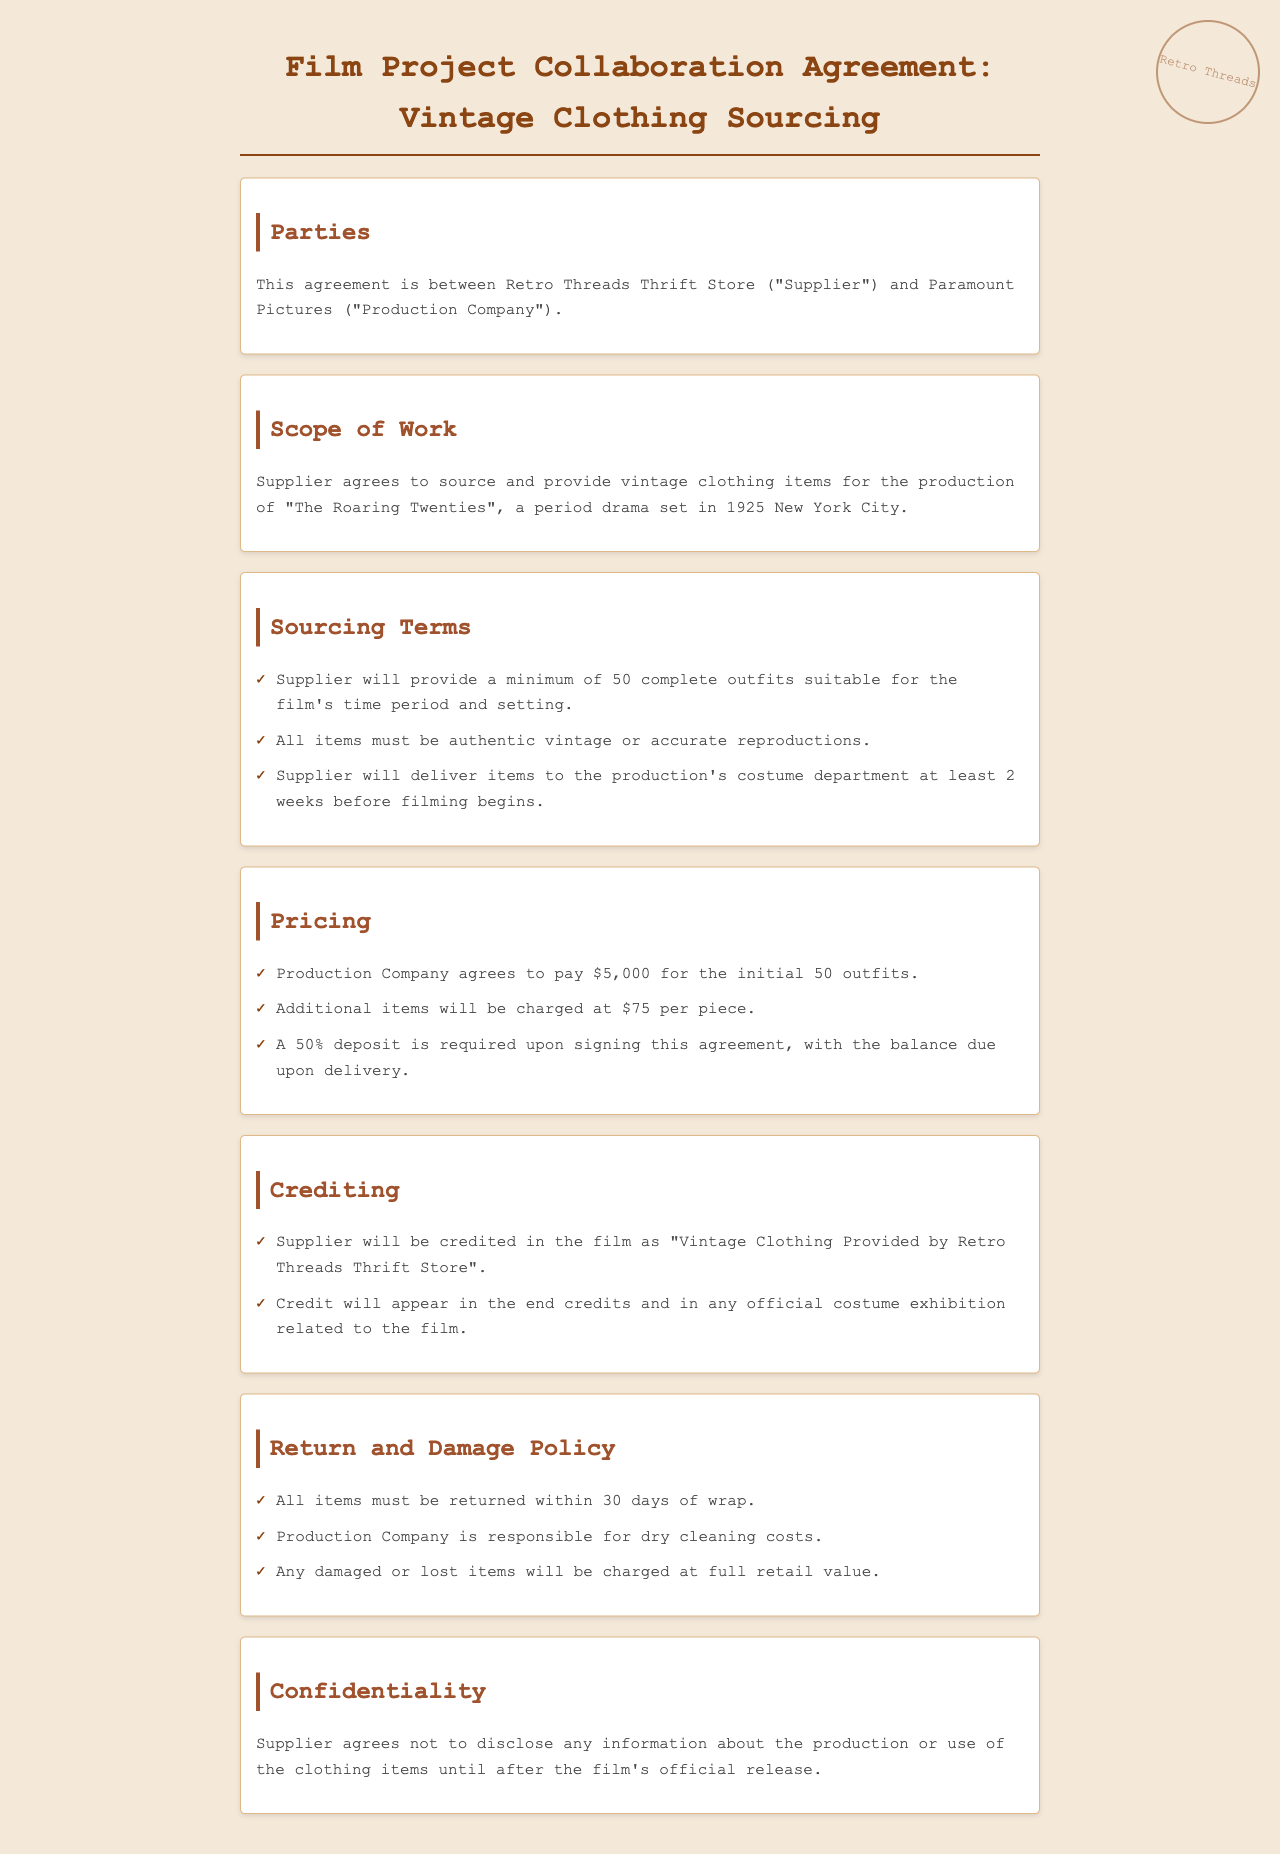what is the name of the production company? The production company mentioned in the document is Paramount Pictures.
Answer: Paramount Pictures how many outfits must the supplier provide? The agreement states that the supplier will provide a minimum of 50 outfits.
Answer: 50 outfits what is the payment amount for the initial 50 outfits? The production company agrees to pay $5,000 for the initial 50 outfits.
Answer: $5,000 what are the dry cleaning costs responsibility? The production company is responsible for dry cleaning costs as stated in the Return and Damage Policy section.
Answer: Production Company how long does the production company have to return items? The document states that all items must be returned within 30 days of wrap.
Answer: 30 days what will the supplier be credited as in the film? The supplier will be credited as "Vintage Clothing Provided by Retro Threads Thrift Store".
Answer: Vintage Clothing Provided by Retro Threads Thrift Store what is the deposit percentage required upon signing? A 50% deposit is required upon signing the agreement.
Answer: 50% what is considered the scope of work? The supplier agrees to source and provide vintage clothing items for the production of "The Roaring Twenties".
Answer: Vintage clothing for "The Roaring Twenties" what obligations does the supplier have regarding item authenticity? All items must be authentic vintage or accurate reproductions as per the sourcing terms.
Answer: Authentic vintage or accurate reproductions 